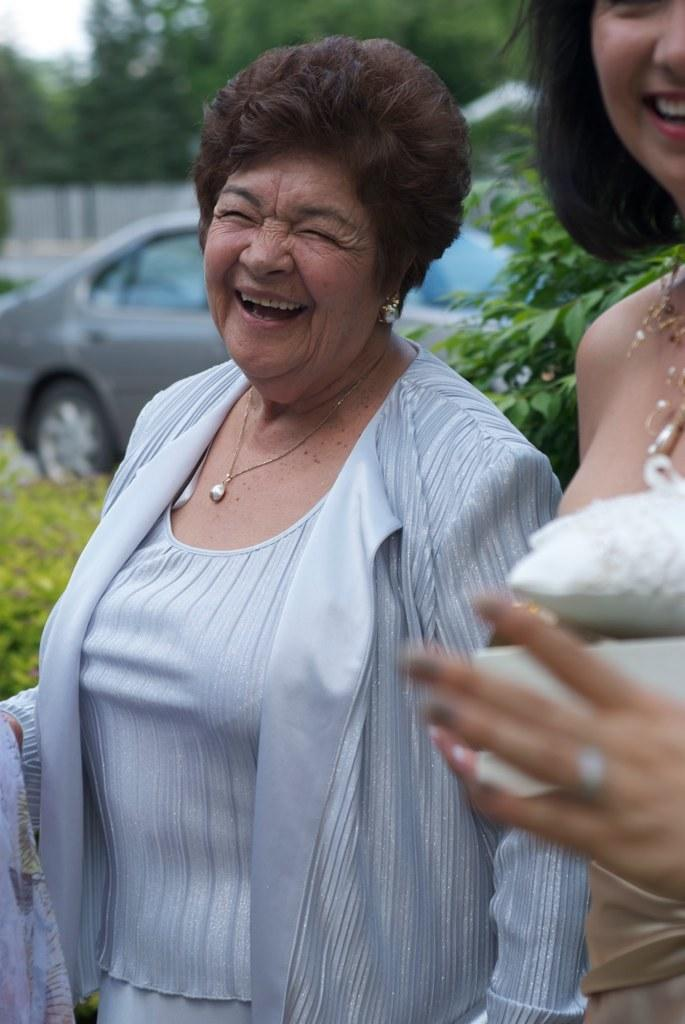What can be seen in the image? There are women standing in the image, and a car is parked nearby. What is the condition of the women in the image? The women have smiles on their faces. What else can be seen in the background of the image? There are trees visible in the image. Reasoning: Let'g: Let's think step by step in order to produce the conversation. We start by identifying the main subjects in the image, which are the women and the parked car. Then, we describe the condition of the women, noting that they have smiles on their faces. Finally, we mention the presence of trees in the background, which adds context to the setting. Absurd Question/Answer: How many flags can be seen in the image? There are no flags visible in the image. Are there any bikes present in the image? There is no mention of bikes in the provided facts, so we cannot determine their presence from the image. How many flags can be seen in the image? There are no flags visible in the image. Are there any bikes present in the image? There is no mention of bikes in the provided facts, so we cannot determine their presence from the image. 